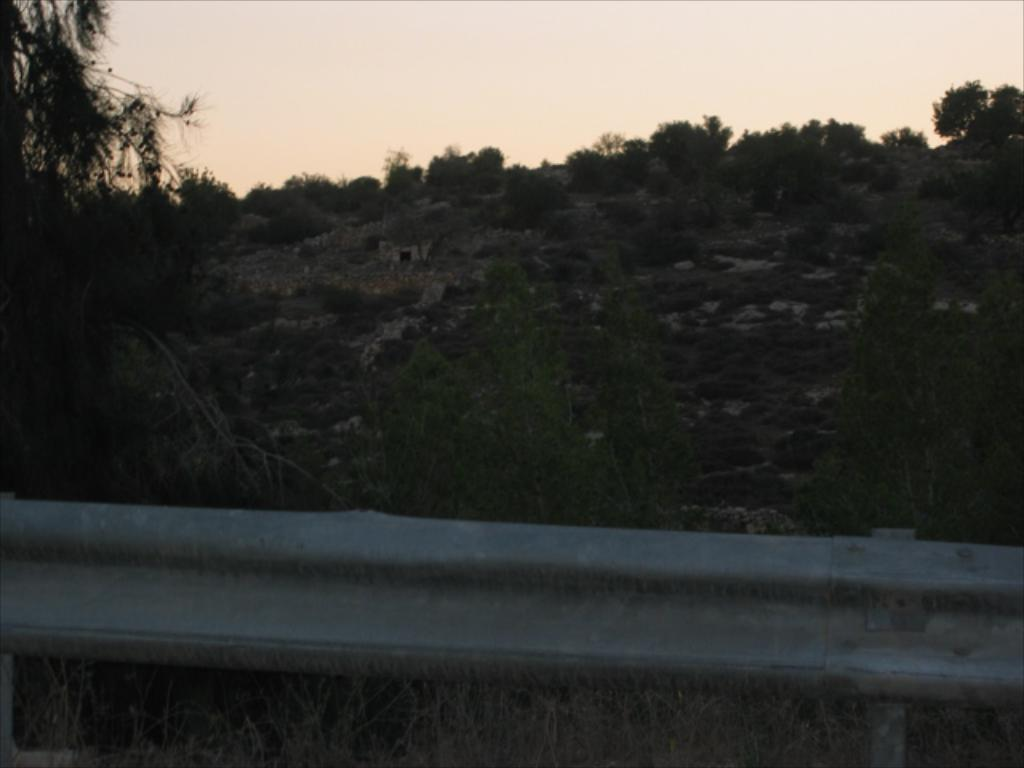What can be seen in the middle of the image? There are trees, houses, and a fence in the middle of the image. Can you describe the background of the image? The sky is visible in the background of the image. What type of stone can be seen rolling down the hill in the image? There is no stone or hill present in the image. How does the pickle move around in the image? There is no pickle present in the image, so it cannot move around. 